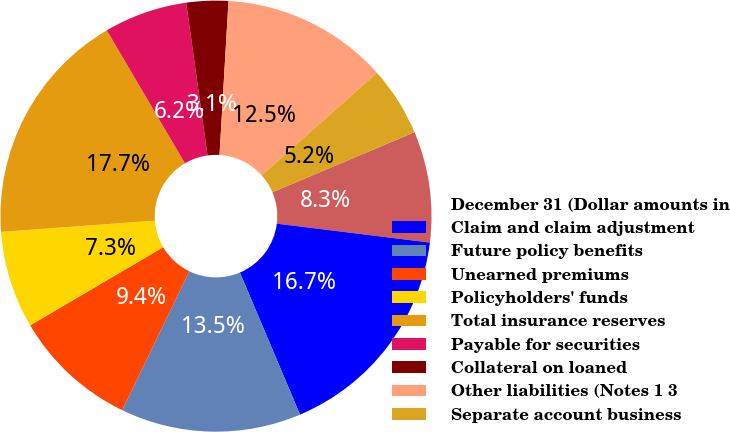<chart> <loc_0><loc_0><loc_500><loc_500><pie_chart><fcel>December 31 (Dollar amounts in<fcel>Claim and claim adjustment<fcel>Future policy benefits<fcel>Unearned premiums<fcel>Policyholders' funds<fcel>Total insurance reserves<fcel>Payable for securities<fcel>Collateral on loaned<fcel>Other liabilities (Notes 1 3<fcel>Separate account business<nl><fcel>8.33%<fcel>16.67%<fcel>13.54%<fcel>9.38%<fcel>7.29%<fcel>17.71%<fcel>6.25%<fcel>3.13%<fcel>12.5%<fcel>5.21%<nl></chart> 